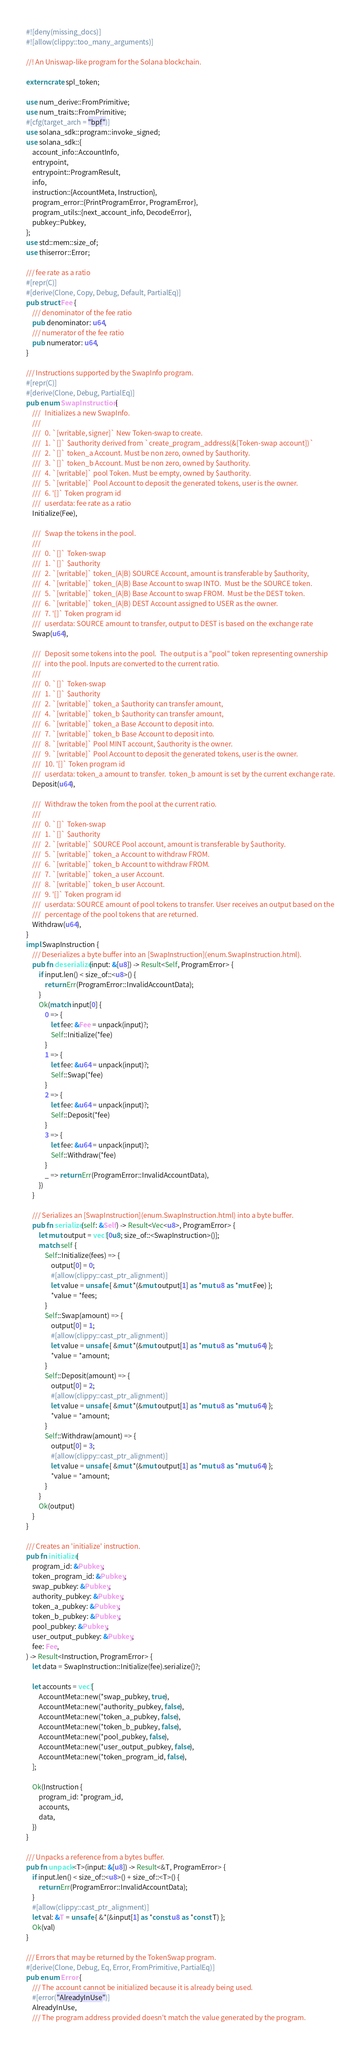<code> <loc_0><loc_0><loc_500><loc_500><_Rust_>#![deny(missing_docs)]
#![allow(clippy::too_many_arguments)]

//! An Uniswap-like program for the Solana blockchain.

extern crate spl_token;

use num_derive::FromPrimitive;
use num_traits::FromPrimitive;
#[cfg(target_arch = "bpf")]
use solana_sdk::program::invoke_signed;
use solana_sdk::{
    account_info::AccountInfo,
    entrypoint,
    entrypoint::ProgramResult,
    info,
    instruction::{AccountMeta, Instruction},
    program_error::{PrintProgramError, ProgramError},
    program_utils::{next_account_info, DecodeError},
    pubkey::Pubkey,
};
use std::mem::size_of;
use thiserror::Error;

/// fee rate as a ratio
#[repr(C)]
#[derive(Clone, Copy, Debug, Default, PartialEq)]
pub struct Fee {
    /// denominator of the fee ratio
    pub denominator: u64,
    /// numerator of the fee ratio
    pub numerator: u64,
}

/// Instructions supported by the SwapInfo program.
#[repr(C)]
#[derive(Clone, Debug, PartialEq)]
pub enum SwapInstruction {
    ///   Initializes a new SwapInfo.
    ///
    ///   0. `[writable, signer]` New Token-swap to create.
    ///   1. `[]` $authority derived from `create_program_address(&[Token-swap account])`
    ///   2. `[]` token_a Account. Must be non zero, owned by $authority.
    ///   3. `[]` token_b Account. Must be non zero, owned by $authority.
    ///   4. `[writable]` pool Token. Must be empty, owned by $authority.
    ///   5. `[writable]` Pool Account to deposit the generated tokens, user is the owner.
    ///   6. '[]` Token program id
    ///   userdata: fee rate as a ratio
    Initialize(Fee),

    ///   Swap the tokens in the pool.
    ///
    ///   0. `[]` Token-swap
    ///   1. `[]` $authority
    ///   2. `[writable]` token_(A|B) SOURCE Account, amount is transferable by $authority,
    ///   4. `[writable]` token_(A|B) Base Account to swap INTO.  Must be the SOURCE token.
    ///   5. `[writable]` token_(A|B) Base Account to swap FROM.  Must be the DEST token.
    ///   6. `[writable]` token_(A|B) DEST Account assigned to USER as the owner.
    ///   7. '[]` Token program id
    ///   userdata: SOURCE amount to transfer, output to DEST is based on the exchange rate
    Swap(u64),

    ///   Deposit some tokens into the pool.  The output is a "pool" token representing ownership
    ///   into the pool. Inputs are converted to the current ratio.
    ///
    ///   0. `[]` Token-swap
    ///   1. `[]` $authority
    ///   2. `[writable]` token_a $authority can transfer amount,
    ///   4. `[writable]` token_b $authority can transfer amount,
    ///   6. `[writable]` token_a Base Account to deposit into.
    ///   7. `[writable]` token_b Base Account to deposit into.
    ///   8. `[writable]` Pool MINT account, $authority is the owner.
    ///   9. `[writable]` Pool Account to deposit the generated tokens, user is the owner.
    ///   10. '[]` Token program id
    ///   userdata: token_a amount to transfer.  token_b amount is set by the current exchange rate.
    Deposit(u64),

    ///   Withdraw the token from the pool at the current ratio.
    ///   
    ///   0. `[]` Token-swap
    ///   1. `[]` $authority
    ///   2. `[writable]` SOURCE Pool account, amount is transferable by $authority.
    ///   5. `[writable]` token_a Account to withdraw FROM.
    ///   6. `[writable]` token_b Account to withdraw FROM.
    ///   7. `[writable]` token_a user Account.
    ///   8. `[writable]` token_b user Account.
    ///   9. '[]` Token program id
    ///   userdata: SOURCE amount of pool tokens to transfer. User receives an output based on the
    ///   percentage of the pool tokens that are returned.
    Withdraw(u64),
}
impl SwapInstruction {
    /// Deserializes a byte buffer into an [SwapInstruction](enum.SwapInstruction.html).
    pub fn deserialize(input: &[u8]) -> Result<Self, ProgramError> {
        if input.len() < size_of::<u8>() {
            return Err(ProgramError::InvalidAccountData);
        }
        Ok(match input[0] {
            0 => {
                let fee: &Fee = unpack(input)?;
                Self::Initialize(*fee)
            }
            1 => {
                let fee: &u64 = unpack(input)?;
                Self::Swap(*fee)
            }
            2 => {
                let fee: &u64 = unpack(input)?;
                Self::Deposit(*fee)
            }
            3 => {
                let fee: &u64 = unpack(input)?;
                Self::Withdraw(*fee)
            }
            _ => return Err(ProgramError::InvalidAccountData),
        })
    }

    /// Serializes an [SwapInstruction](enum.SwapInstruction.html) into a byte buffer.
    pub fn serialize(self: &Self) -> Result<Vec<u8>, ProgramError> {
        let mut output = vec![0u8; size_of::<SwapInstruction>()];
        match self {
            Self::Initialize(fees) => {
                output[0] = 0;
                #[allow(clippy::cast_ptr_alignment)]
                let value = unsafe { &mut *(&mut output[1] as *mut u8 as *mut Fee) };
                *value = *fees;
            }
            Self::Swap(amount) => {
                output[0] = 1;
                #[allow(clippy::cast_ptr_alignment)]
                let value = unsafe { &mut *(&mut output[1] as *mut u8 as *mut u64) };
                *value = *amount;
            }
            Self::Deposit(amount) => {
                output[0] = 2;
                #[allow(clippy::cast_ptr_alignment)]
                let value = unsafe { &mut *(&mut output[1] as *mut u8 as *mut u64) };
                *value = *amount;
            }
            Self::Withdraw(amount) => {
                output[0] = 3;
                #[allow(clippy::cast_ptr_alignment)]
                let value = unsafe { &mut *(&mut output[1] as *mut u8 as *mut u64) };
                *value = *amount;
            }
        }
        Ok(output)
    }
}

/// Creates an 'initialize' instruction.
pub fn initialize(
    program_id: &Pubkey,
    token_program_id: &Pubkey,
    swap_pubkey: &Pubkey,
    authority_pubkey: &Pubkey,
    token_a_pubkey: &Pubkey,
    token_b_pubkey: &Pubkey,
    pool_pubkey: &Pubkey,
    user_output_pubkey: &Pubkey,
    fee: Fee,
) -> Result<Instruction, ProgramError> {
    let data = SwapInstruction::Initialize(fee).serialize()?;

    let accounts = vec![
        AccountMeta::new(*swap_pubkey, true),
        AccountMeta::new(*authority_pubkey, false),
        AccountMeta::new(*token_a_pubkey, false),
        AccountMeta::new(*token_b_pubkey, false),
        AccountMeta::new(*pool_pubkey, false),
        AccountMeta::new(*user_output_pubkey, false),
        AccountMeta::new(*token_program_id, false),
    ];

    Ok(Instruction {
        program_id: *program_id,
        accounts,
        data,
    })
}

/// Unpacks a reference from a bytes buffer.
pub fn unpack<T>(input: &[u8]) -> Result<&T, ProgramError> {
    if input.len() < size_of::<u8>() + size_of::<T>() {
        return Err(ProgramError::InvalidAccountData);
    }
    #[allow(clippy::cast_ptr_alignment)]
    let val: &T = unsafe { &*(&input[1] as *const u8 as *const T) };
    Ok(val)
}

/// Errors that may be returned by the TokenSwap program.
#[derive(Clone, Debug, Eq, Error, FromPrimitive, PartialEq)]
pub enum Error {
    /// The account cannot be initialized because it is already being used.
    #[error("AlreadyInUse")]
    AlreadyInUse,
    /// The program address provided doesn't match the value generated by the program.</code> 